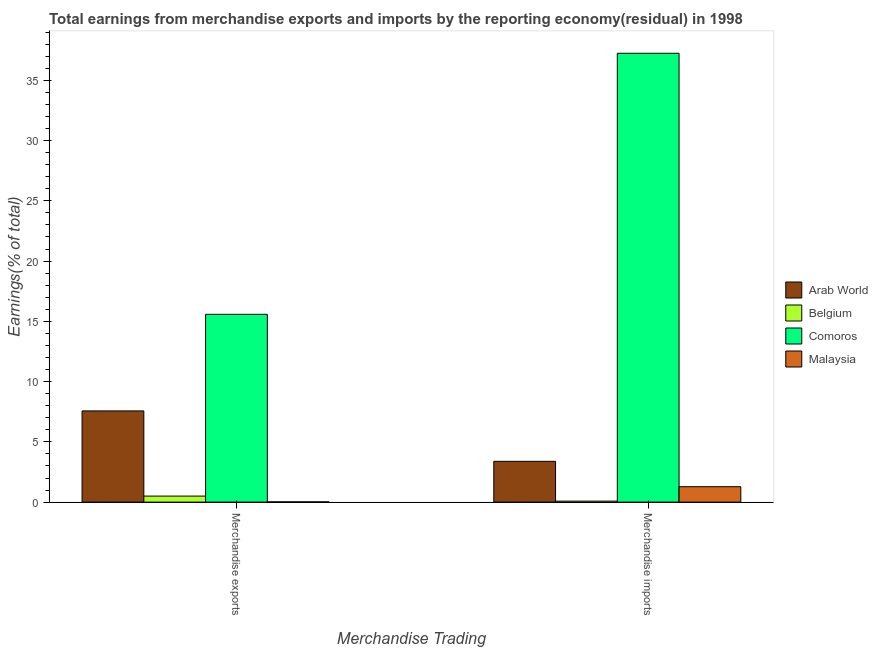How many different coloured bars are there?
Ensure brevity in your answer.  4. How many bars are there on the 2nd tick from the left?
Provide a succinct answer. 4. How many bars are there on the 2nd tick from the right?
Give a very brief answer. 4. What is the earnings from merchandise exports in Malaysia?
Your answer should be very brief. 0.02. Across all countries, what is the maximum earnings from merchandise exports?
Make the answer very short. 15.58. Across all countries, what is the minimum earnings from merchandise imports?
Make the answer very short. 0.08. In which country was the earnings from merchandise imports maximum?
Provide a short and direct response. Comoros. In which country was the earnings from merchandise exports minimum?
Your answer should be very brief. Malaysia. What is the total earnings from merchandise exports in the graph?
Ensure brevity in your answer.  23.67. What is the difference between the earnings from merchandise exports in Comoros and that in Belgium?
Keep it short and to the point. 15.08. What is the difference between the earnings from merchandise imports in Arab World and the earnings from merchandise exports in Belgium?
Provide a short and direct response. 2.88. What is the average earnings from merchandise imports per country?
Your answer should be compact. 10.5. What is the difference between the earnings from merchandise exports and earnings from merchandise imports in Malaysia?
Your response must be concise. -1.26. In how many countries, is the earnings from merchandise exports greater than 34 %?
Make the answer very short. 0. What is the ratio of the earnings from merchandise imports in Comoros to that in Arab World?
Offer a terse response. 11. What does the 3rd bar from the left in Merchandise exports represents?
Keep it short and to the point. Comoros. What does the 3rd bar from the right in Merchandise exports represents?
Your answer should be compact. Belgium. How many bars are there?
Make the answer very short. 8. How many countries are there in the graph?
Make the answer very short. 4. What is the difference between two consecutive major ticks on the Y-axis?
Ensure brevity in your answer.  5. Are the values on the major ticks of Y-axis written in scientific E-notation?
Ensure brevity in your answer.  No. Does the graph contain grids?
Ensure brevity in your answer.  No. Where does the legend appear in the graph?
Ensure brevity in your answer.  Center right. How are the legend labels stacked?
Give a very brief answer. Vertical. What is the title of the graph?
Your response must be concise. Total earnings from merchandise exports and imports by the reporting economy(residual) in 1998. Does "Italy" appear as one of the legend labels in the graph?
Your answer should be very brief. No. What is the label or title of the X-axis?
Your response must be concise. Merchandise Trading. What is the label or title of the Y-axis?
Make the answer very short. Earnings(% of total). What is the Earnings(% of total) in Arab World in Merchandise exports?
Provide a short and direct response. 7.57. What is the Earnings(% of total) in Belgium in Merchandise exports?
Your answer should be very brief. 0.5. What is the Earnings(% of total) in Comoros in Merchandise exports?
Your answer should be very brief. 15.58. What is the Earnings(% of total) in Malaysia in Merchandise exports?
Your answer should be compact. 0.02. What is the Earnings(% of total) of Arab World in Merchandise imports?
Provide a succinct answer. 3.39. What is the Earnings(% of total) in Belgium in Merchandise imports?
Give a very brief answer. 0.08. What is the Earnings(% of total) of Comoros in Merchandise imports?
Your answer should be compact. 37.24. What is the Earnings(% of total) in Malaysia in Merchandise imports?
Your answer should be very brief. 1.28. Across all Merchandise Trading, what is the maximum Earnings(% of total) in Arab World?
Provide a short and direct response. 7.57. Across all Merchandise Trading, what is the maximum Earnings(% of total) in Belgium?
Your response must be concise. 0.5. Across all Merchandise Trading, what is the maximum Earnings(% of total) in Comoros?
Your answer should be compact. 37.24. Across all Merchandise Trading, what is the maximum Earnings(% of total) in Malaysia?
Offer a terse response. 1.28. Across all Merchandise Trading, what is the minimum Earnings(% of total) in Arab World?
Ensure brevity in your answer.  3.39. Across all Merchandise Trading, what is the minimum Earnings(% of total) in Belgium?
Offer a very short reply. 0.08. Across all Merchandise Trading, what is the minimum Earnings(% of total) in Comoros?
Your answer should be very brief. 15.58. Across all Merchandise Trading, what is the minimum Earnings(% of total) in Malaysia?
Provide a succinct answer. 0.02. What is the total Earnings(% of total) in Arab World in the graph?
Ensure brevity in your answer.  10.95. What is the total Earnings(% of total) of Belgium in the graph?
Provide a succinct answer. 0.58. What is the total Earnings(% of total) in Comoros in the graph?
Give a very brief answer. 52.83. What is the total Earnings(% of total) in Malaysia in the graph?
Offer a very short reply. 1.3. What is the difference between the Earnings(% of total) in Arab World in Merchandise exports and that in Merchandise imports?
Your answer should be compact. 4.18. What is the difference between the Earnings(% of total) in Belgium in Merchandise exports and that in Merchandise imports?
Keep it short and to the point. 0.42. What is the difference between the Earnings(% of total) in Comoros in Merchandise exports and that in Merchandise imports?
Offer a very short reply. -21.66. What is the difference between the Earnings(% of total) in Malaysia in Merchandise exports and that in Merchandise imports?
Give a very brief answer. -1.26. What is the difference between the Earnings(% of total) in Arab World in Merchandise exports and the Earnings(% of total) in Belgium in Merchandise imports?
Provide a short and direct response. 7.49. What is the difference between the Earnings(% of total) in Arab World in Merchandise exports and the Earnings(% of total) in Comoros in Merchandise imports?
Provide a succinct answer. -29.67. What is the difference between the Earnings(% of total) of Arab World in Merchandise exports and the Earnings(% of total) of Malaysia in Merchandise imports?
Keep it short and to the point. 6.29. What is the difference between the Earnings(% of total) in Belgium in Merchandise exports and the Earnings(% of total) in Comoros in Merchandise imports?
Keep it short and to the point. -36.74. What is the difference between the Earnings(% of total) of Belgium in Merchandise exports and the Earnings(% of total) of Malaysia in Merchandise imports?
Make the answer very short. -0.78. What is the difference between the Earnings(% of total) of Comoros in Merchandise exports and the Earnings(% of total) of Malaysia in Merchandise imports?
Your answer should be very brief. 14.3. What is the average Earnings(% of total) of Arab World per Merchandise Trading?
Make the answer very short. 5.48. What is the average Earnings(% of total) of Belgium per Merchandise Trading?
Give a very brief answer. 0.29. What is the average Earnings(% of total) in Comoros per Merchandise Trading?
Offer a very short reply. 26.41. What is the average Earnings(% of total) in Malaysia per Merchandise Trading?
Your answer should be very brief. 0.65. What is the difference between the Earnings(% of total) of Arab World and Earnings(% of total) of Belgium in Merchandise exports?
Offer a terse response. 7.07. What is the difference between the Earnings(% of total) of Arab World and Earnings(% of total) of Comoros in Merchandise exports?
Make the answer very short. -8.02. What is the difference between the Earnings(% of total) of Arab World and Earnings(% of total) of Malaysia in Merchandise exports?
Offer a terse response. 7.55. What is the difference between the Earnings(% of total) of Belgium and Earnings(% of total) of Comoros in Merchandise exports?
Give a very brief answer. -15.08. What is the difference between the Earnings(% of total) in Belgium and Earnings(% of total) in Malaysia in Merchandise exports?
Your response must be concise. 0.48. What is the difference between the Earnings(% of total) in Comoros and Earnings(% of total) in Malaysia in Merchandise exports?
Provide a short and direct response. 15.56. What is the difference between the Earnings(% of total) of Arab World and Earnings(% of total) of Belgium in Merchandise imports?
Offer a terse response. 3.3. What is the difference between the Earnings(% of total) of Arab World and Earnings(% of total) of Comoros in Merchandise imports?
Keep it short and to the point. -33.86. What is the difference between the Earnings(% of total) of Arab World and Earnings(% of total) of Malaysia in Merchandise imports?
Give a very brief answer. 2.11. What is the difference between the Earnings(% of total) of Belgium and Earnings(% of total) of Comoros in Merchandise imports?
Your answer should be very brief. -37.16. What is the difference between the Earnings(% of total) of Belgium and Earnings(% of total) of Malaysia in Merchandise imports?
Provide a short and direct response. -1.2. What is the difference between the Earnings(% of total) in Comoros and Earnings(% of total) in Malaysia in Merchandise imports?
Offer a very short reply. 35.96. What is the ratio of the Earnings(% of total) in Arab World in Merchandise exports to that in Merchandise imports?
Your response must be concise. 2.23. What is the ratio of the Earnings(% of total) in Belgium in Merchandise exports to that in Merchandise imports?
Provide a short and direct response. 6.09. What is the ratio of the Earnings(% of total) of Comoros in Merchandise exports to that in Merchandise imports?
Your answer should be compact. 0.42. What is the ratio of the Earnings(% of total) in Malaysia in Merchandise exports to that in Merchandise imports?
Offer a terse response. 0.02. What is the difference between the highest and the second highest Earnings(% of total) of Arab World?
Offer a terse response. 4.18. What is the difference between the highest and the second highest Earnings(% of total) of Belgium?
Make the answer very short. 0.42. What is the difference between the highest and the second highest Earnings(% of total) in Comoros?
Offer a very short reply. 21.66. What is the difference between the highest and the second highest Earnings(% of total) of Malaysia?
Make the answer very short. 1.26. What is the difference between the highest and the lowest Earnings(% of total) in Arab World?
Offer a terse response. 4.18. What is the difference between the highest and the lowest Earnings(% of total) in Belgium?
Offer a very short reply. 0.42. What is the difference between the highest and the lowest Earnings(% of total) in Comoros?
Offer a terse response. 21.66. What is the difference between the highest and the lowest Earnings(% of total) in Malaysia?
Ensure brevity in your answer.  1.26. 